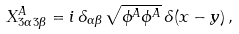<formula> <loc_0><loc_0><loc_500><loc_500>X _ { 3 \alpha \, 3 \beta } ^ { A } = i \, \delta _ { \alpha \beta } \, \sqrt { \phi ^ { A } \phi ^ { A } } \, \delta ( x - y ) \, ,</formula> 